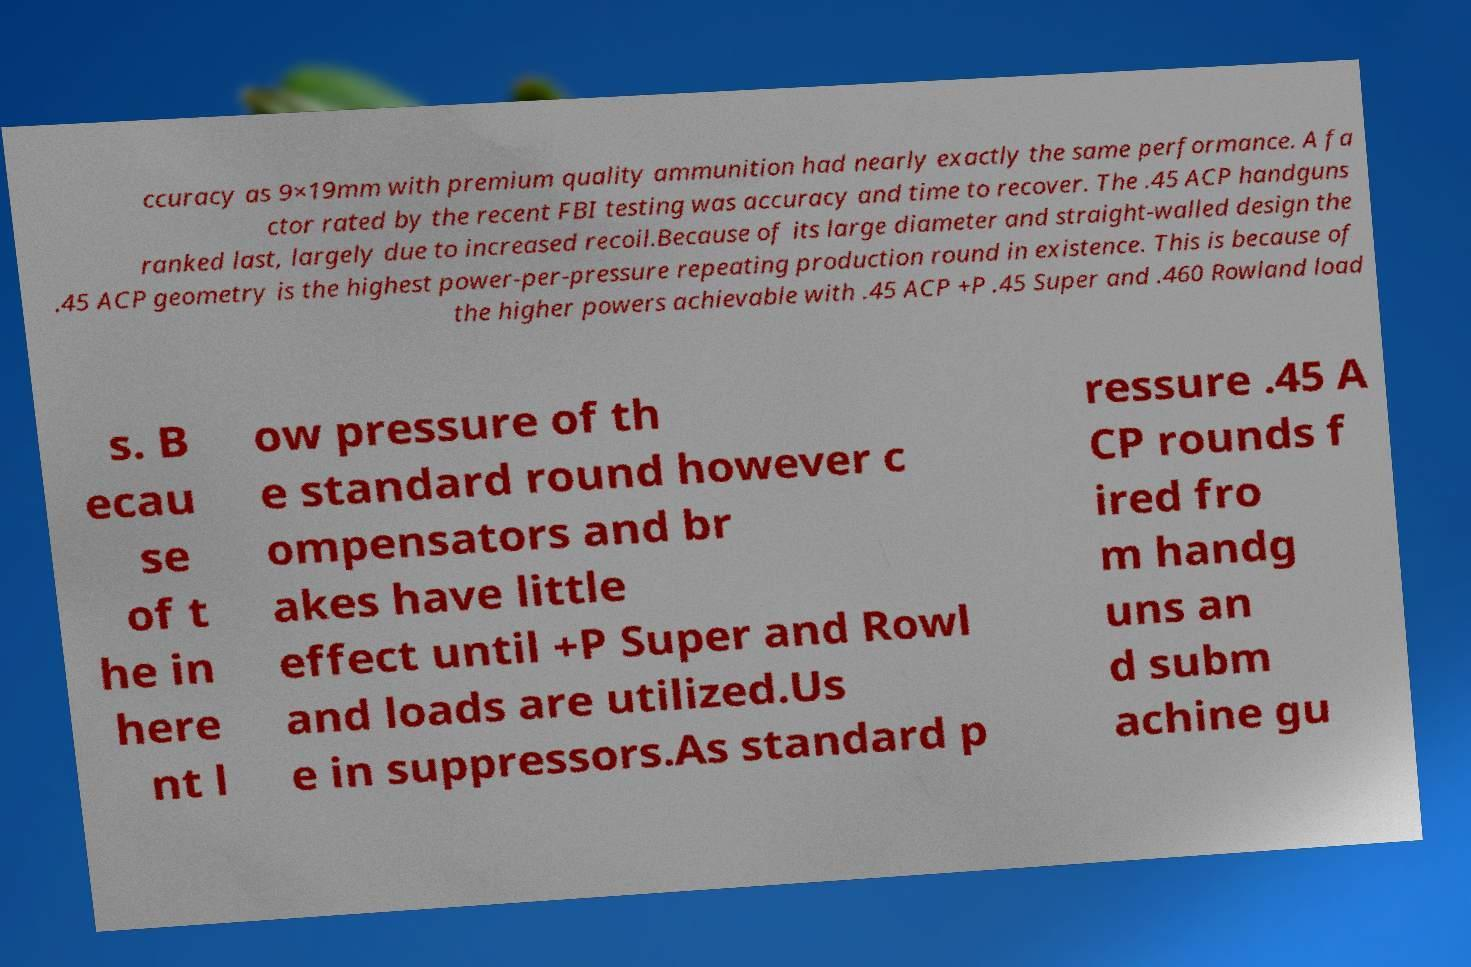There's text embedded in this image that I need extracted. Can you transcribe it verbatim? ccuracy as 9×19mm with premium quality ammunition had nearly exactly the same performance. A fa ctor rated by the recent FBI testing was accuracy and time to recover. The .45 ACP handguns ranked last, largely due to increased recoil.Because of its large diameter and straight-walled design the .45 ACP geometry is the highest power-per-pressure repeating production round in existence. This is because of the higher powers achievable with .45 ACP +P .45 Super and .460 Rowland load s. B ecau se of t he in here nt l ow pressure of th e standard round however c ompensators and br akes have little effect until +P Super and Rowl and loads are utilized.Us e in suppressors.As standard p ressure .45 A CP rounds f ired fro m handg uns an d subm achine gu 